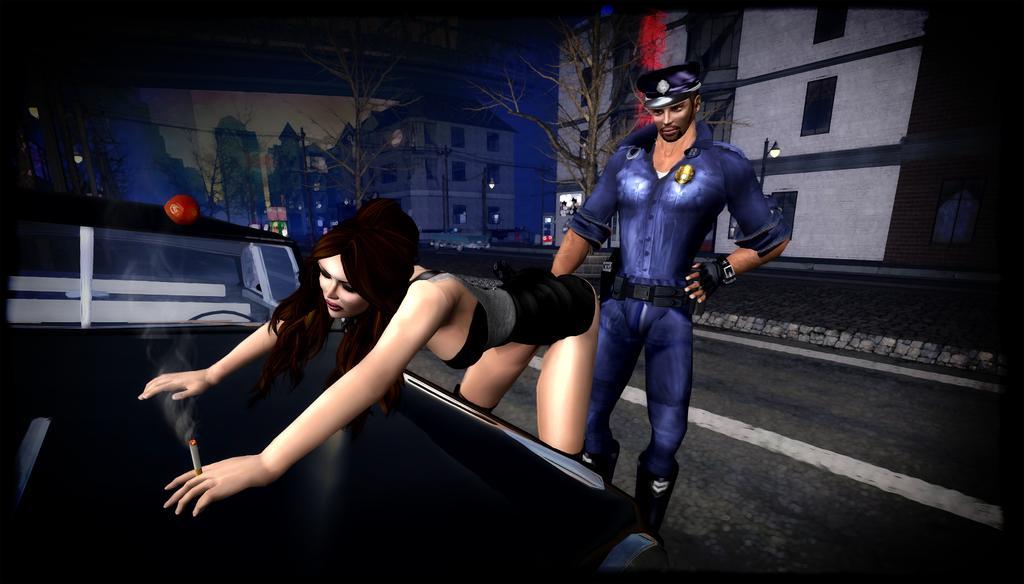Describe this image in one or two sentences. This is an animated image. There are a few people. We can see a vehicle. There are a few poles, trees. We can see the wall. There are a few buildings, wires. We can see the ground and the sky. 